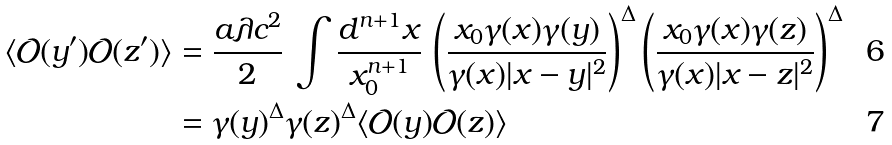Convert formula to latex. <formula><loc_0><loc_0><loc_500><loc_500>\langle \mathcal { O } ( y ^ { \prime } ) \mathcal { O } ( z ^ { \prime } ) \rangle & = \frac { a \lambda c ^ { 2 } } { 2 } \, \int \frac { d ^ { n + 1 } x } { x _ { 0 } ^ { n + 1 } } \, \left ( \frac { x _ { 0 } \gamma ( x ) \gamma ( y ) } { \gamma ( x ) | x - y | ^ { 2 } } \right ) ^ { \Delta } \left ( \frac { x _ { 0 } \gamma ( x ) \gamma ( z ) } { \gamma ( x ) | x - z | ^ { 2 } } \right ) ^ { \Delta } \\ & = \gamma ( y ) ^ { \Delta } \gamma ( z ) ^ { \Delta } \langle \mathcal { O } ( y ) \mathcal { O } ( z ) \rangle</formula> 